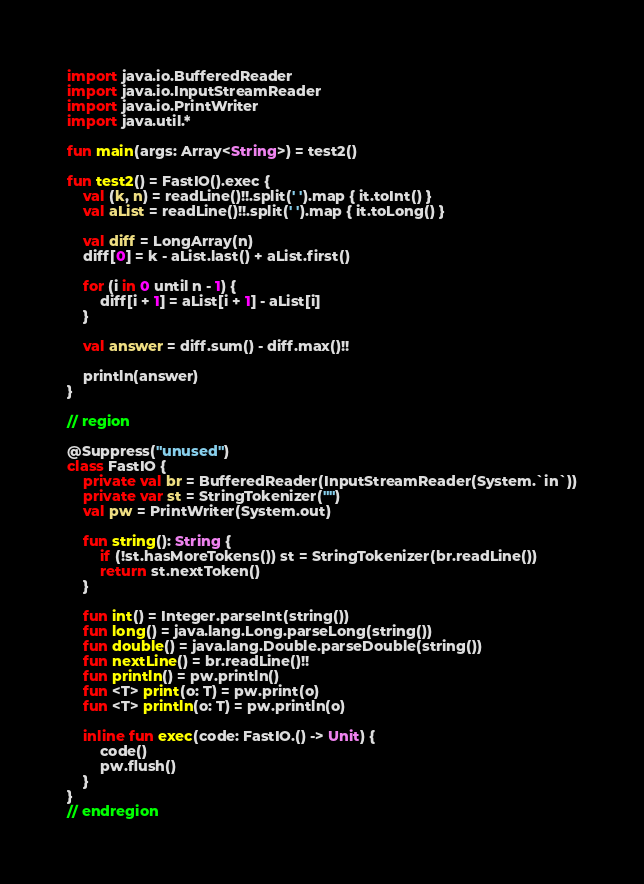Convert code to text. <code><loc_0><loc_0><loc_500><loc_500><_Kotlin_>import java.io.BufferedReader
import java.io.InputStreamReader
import java.io.PrintWriter
import java.util.*

fun main(args: Array<String>) = test2()

fun test2() = FastIO().exec {
    val (k, n) = readLine()!!.split(' ').map { it.toInt() }
    val aList = readLine()!!.split(' ').map { it.toLong() }

    val diff = LongArray(n)
    diff[0] = k - aList.last() + aList.first()

    for (i in 0 until n - 1) {
        diff[i + 1] = aList[i + 1] - aList[i]
    }

    val answer = diff.sum() - diff.max()!!

    println(answer)
}

// region

@Suppress("unused")
class FastIO {
    private val br = BufferedReader(InputStreamReader(System.`in`))
    private var st = StringTokenizer("")
    val pw = PrintWriter(System.out)

    fun string(): String {
        if (!st.hasMoreTokens()) st = StringTokenizer(br.readLine())
        return st.nextToken()
    }

    fun int() = Integer.parseInt(string())
    fun long() = java.lang.Long.parseLong(string())
    fun double() = java.lang.Double.parseDouble(string())
    fun nextLine() = br.readLine()!!
    fun println() = pw.println()
    fun <T> print(o: T) = pw.print(o)
    fun <T> println(o: T) = pw.println(o)

    inline fun exec(code: FastIO.() -> Unit) {
        code()
        pw.flush()
    }
}
// endregion
</code> 